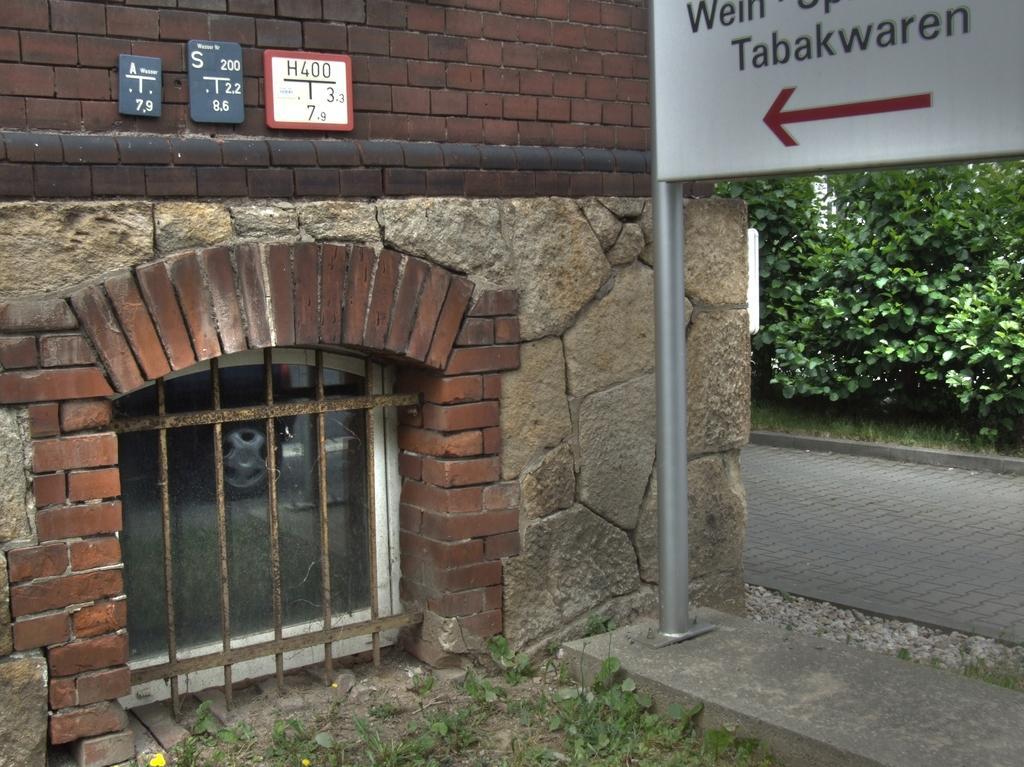Can you describe this image briefly? In this image on the right side there is one house and on the left side there is one board and trees, at the bottom there is a walkway and some grass. And on the top of the image there are some boards attached to the house. 